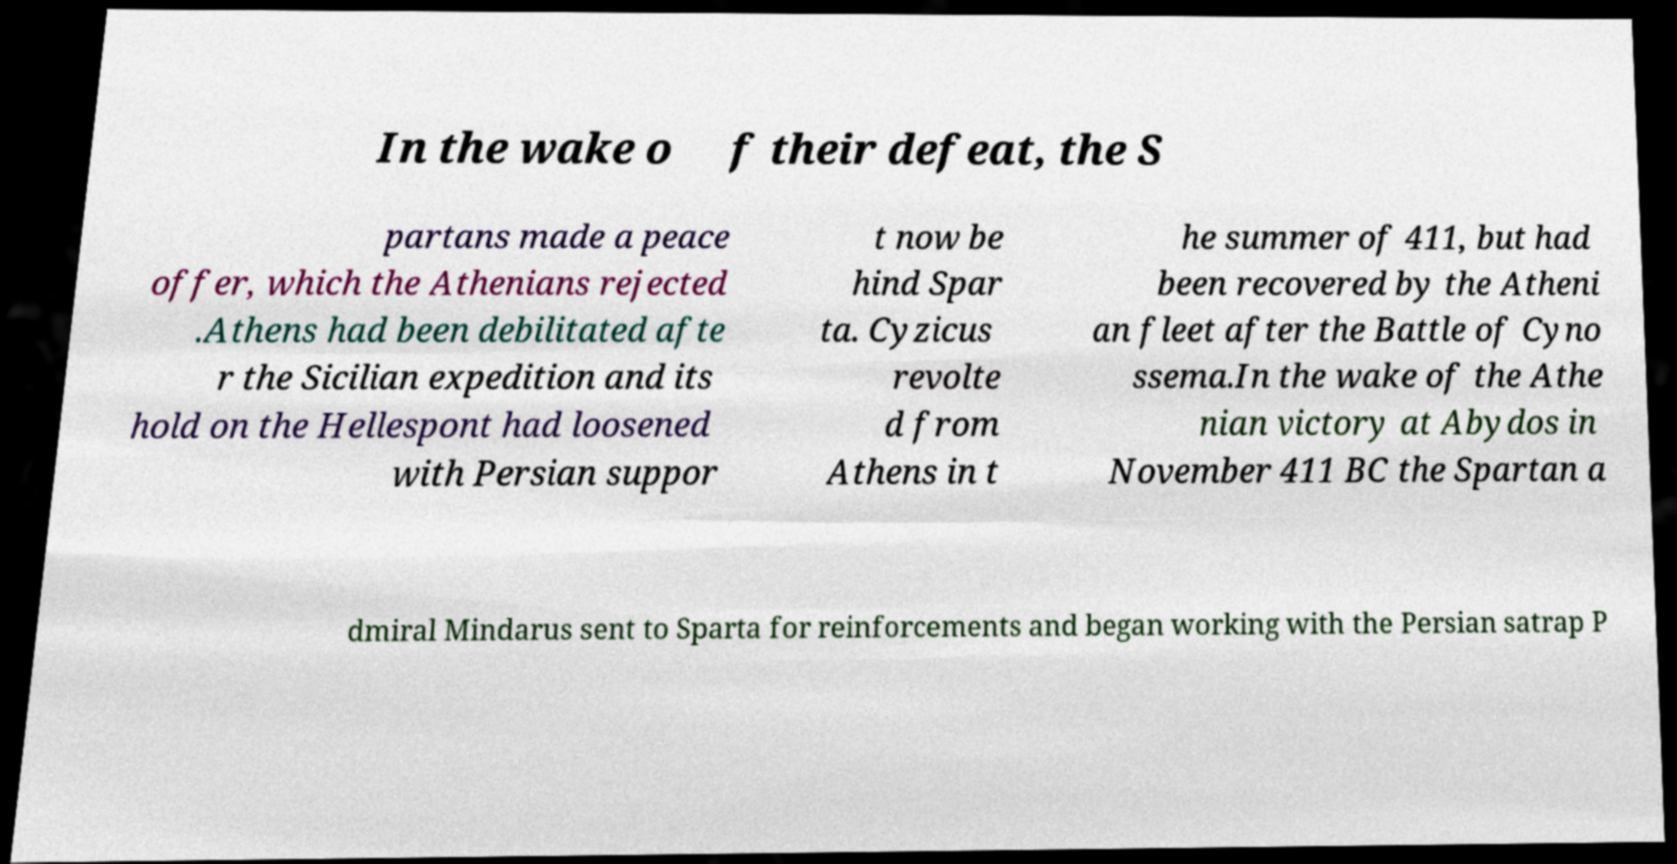Could you assist in decoding the text presented in this image and type it out clearly? In the wake o f their defeat, the S partans made a peace offer, which the Athenians rejected .Athens had been debilitated afte r the Sicilian expedition and its hold on the Hellespont had loosened with Persian suppor t now be hind Spar ta. Cyzicus revolte d from Athens in t he summer of 411, but had been recovered by the Atheni an fleet after the Battle of Cyno ssema.In the wake of the Athe nian victory at Abydos in November 411 BC the Spartan a dmiral Mindarus sent to Sparta for reinforcements and began working with the Persian satrap P 